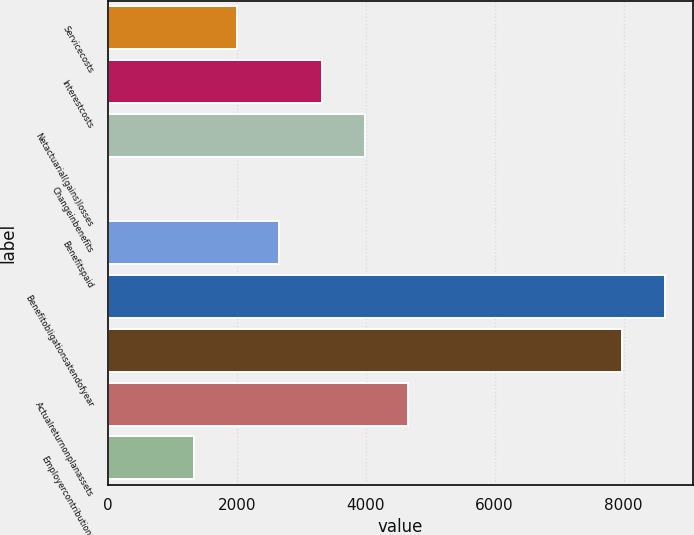<chart> <loc_0><loc_0><loc_500><loc_500><bar_chart><fcel>Servicecosts<fcel>Interestcosts<fcel>Netactuarial(gains)losses<fcel>Changeinbenefits<fcel>Benefitspaid<fcel>Benefitobligationsatendofyear<fcel>Unnamed: 6<fcel>Actualreturnonplanassets<fcel>Employercontributions<nl><fcel>1998.9<fcel>3327.5<fcel>3991.8<fcel>6<fcel>2663.2<fcel>8641.9<fcel>7977.6<fcel>4656.1<fcel>1334.6<nl></chart> 